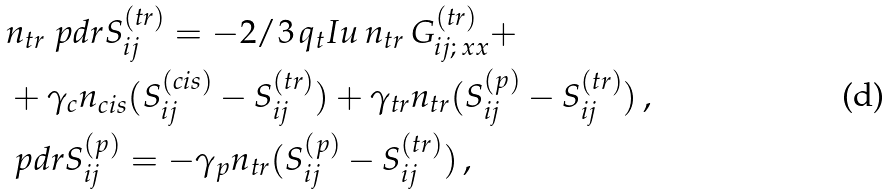Convert formula to latex. <formula><loc_0><loc_0><loc_500><loc_500>& n _ { t r } \ p d r { S _ { i j } ^ { ( t r ) } } = - 2 / 3 \, q _ { t } I u \, n _ { t r } \, G _ { i j ; \, x x } ^ { ( t r ) } + \\ & + \gamma _ { c } n _ { c i s } ( S _ { i j } ^ { ( c i s ) } - S _ { i j } ^ { ( t r ) } ) + \gamma _ { t r } n _ { t r } ( S _ { i j } ^ { ( p ) } - S _ { i j } ^ { ( t r ) } ) \, , \\ & \ p d r { S _ { i j } ^ { ( p ) } } = - \gamma _ { p } n _ { t r } ( S _ { i j } ^ { ( p ) } - S _ { i j } ^ { ( t r ) } ) \, ,</formula> 